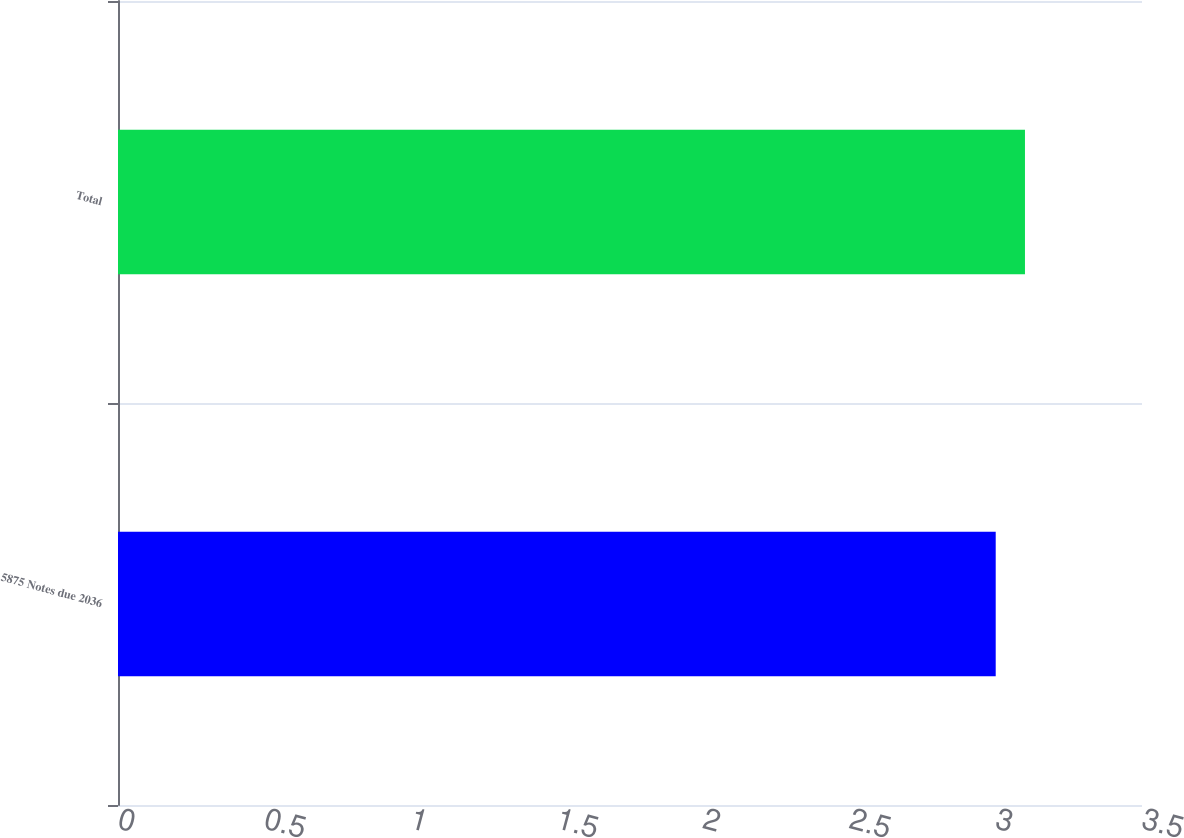Convert chart to OTSL. <chart><loc_0><loc_0><loc_500><loc_500><bar_chart><fcel>5875 Notes due 2036<fcel>Total<nl><fcel>3<fcel>3.1<nl></chart> 